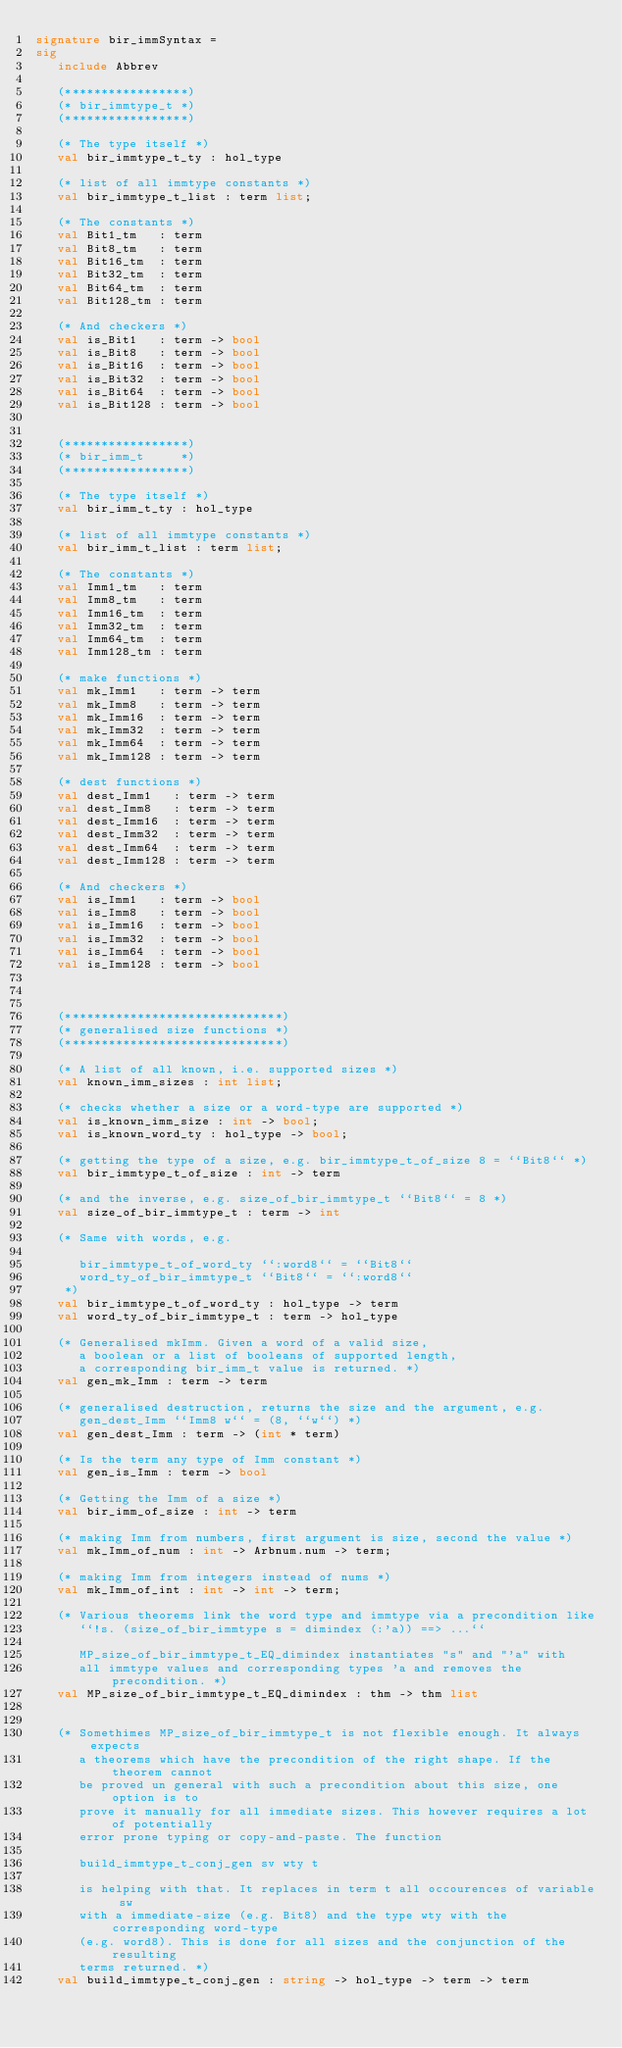<code> <loc_0><loc_0><loc_500><loc_500><_SML_>signature bir_immSyntax =
sig
   include Abbrev

   (*****************)
   (* bir_immtype_t *)
   (*****************)

   (* The type itself *)
   val bir_immtype_t_ty : hol_type

   (* list of all immtype constants *)
   val bir_immtype_t_list : term list;

   (* The constants *)
   val Bit1_tm   : term
   val Bit8_tm   : term
   val Bit16_tm  : term
   val Bit32_tm  : term
   val Bit64_tm  : term
   val Bit128_tm : term

   (* And checkers *)
   val is_Bit1   : term -> bool
   val is_Bit8   : term -> bool
   val is_Bit16  : term -> bool
   val is_Bit32  : term -> bool
   val is_Bit64  : term -> bool
   val is_Bit128 : term -> bool


   (*****************)
   (* bir_imm_t     *)
   (*****************)

   (* The type itself *)
   val bir_imm_t_ty : hol_type

   (* list of all immtype constants *)
   val bir_imm_t_list : term list;

   (* The constants *)
   val Imm1_tm   : term
   val Imm8_tm   : term
   val Imm16_tm  : term
   val Imm32_tm  : term
   val Imm64_tm  : term
   val Imm128_tm : term

   (* make functions *)
   val mk_Imm1   : term -> term
   val mk_Imm8   : term -> term
   val mk_Imm16  : term -> term
   val mk_Imm32  : term -> term
   val mk_Imm64  : term -> term
   val mk_Imm128 : term -> term

   (* dest functions *)
   val dest_Imm1   : term -> term
   val dest_Imm8   : term -> term
   val dest_Imm16  : term -> term
   val dest_Imm32  : term -> term
   val dest_Imm64  : term -> term
   val dest_Imm128 : term -> term

   (* And checkers *)
   val is_Imm1   : term -> bool
   val is_Imm8   : term -> bool
   val is_Imm16  : term -> bool
   val is_Imm32  : term -> bool
   val is_Imm64  : term -> bool
   val is_Imm128 : term -> bool



   (******************************)
   (* generalised size functions *)
   (******************************)

   (* A list of all known, i.e. supported sizes *)
   val known_imm_sizes : int list;

   (* checks whether a size or a word-type are supported *)
   val is_known_imm_size : int -> bool;
   val is_known_word_ty : hol_type -> bool;

   (* getting the type of a size, e.g. bir_immtype_t_of_size 8 = ``Bit8`` *)
   val bir_immtype_t_of_size : int -> term

   (* and the inverse, e.g. size_of_bir_immtype_t ``Bit8`` = 8 *)
   val size_of_bir_immtype_t : term -> int

   (* Same with words, e.g.

      bir_immtype_t_of_word_ty ``:word8`` = ``Bit8``
      word_ty_of_bir_immtype_t ``Bit8`` = ``:word8``
    *)
   val bir_immtype_t_of_word_ty : hol_type -> term
   val word_ty_of_bir_immtype_t : term -> hol_type

   (* Generalised mkImm. Given a word of a valid size,
      a boolean or a list of booleans of supported length,
      a corresponding bir_imm_t value is returned. *)
   val gen_mk_Imm : term -> term

   (* generalised destruction, returns the size and the argument, e.g.
      gen_dest_Imm ``Imm8 w`` = (8, ``w``) *)
   val gen_dest_Imm : term -> (int * term)

   (* Is the term any type of Imm constant *)
   val gen_is_Imm : term -> bool

   (* Getting the Imm of a size *)
   val bir_imm_of_size : int -> term

   (* making Imm from numbers, first argument is size, second the value *)
   val mk_Imm_of_num : int -> Arbnum.num -> term;

   (* making Imm from integers instead of nums *)
   val mk_Imm_of_int : int -> int -> term;

   (* Various theorems link the word type and immtype via a precondition like
      ``!s. (size_of_bir_immtype s = dimindex (:'a)) ==> ...``

      MP_size_of_bir_immtype_t_EQ_dimindex instantiates "s" and "'a" with
      all immtype values and corresponding types 'a and removes the precondition. *)
   val MP_size_of_bir_immtype_t_EQ_dimindex : thm -> thm list


   (* Somethimes MP_size_of_bir_immtype_t is not flexible enough. It always expects
      a theorems which have the precondition of the right shape. If the theorem cannot
      be proved un general with such a precondition about this size, one option is to
      prove it manually for all immediate sizes. This however requires a lot of potentially
      error prone typing or copy-and-paste. The function

      build_immtype_t_conj_gen sv wty t

      is helping with that. It replaces in term t all occourences of variable sw
      with a immediate-size (e.g. Bit8) and the type wty with the corresponding word-type
      (e.g. word8). This is done for all sizes and the conjunction of the resulting
      terms returned. *)
   val build_immtype_t_conj_gen : string -> hol_type -> term -> term
</code> 